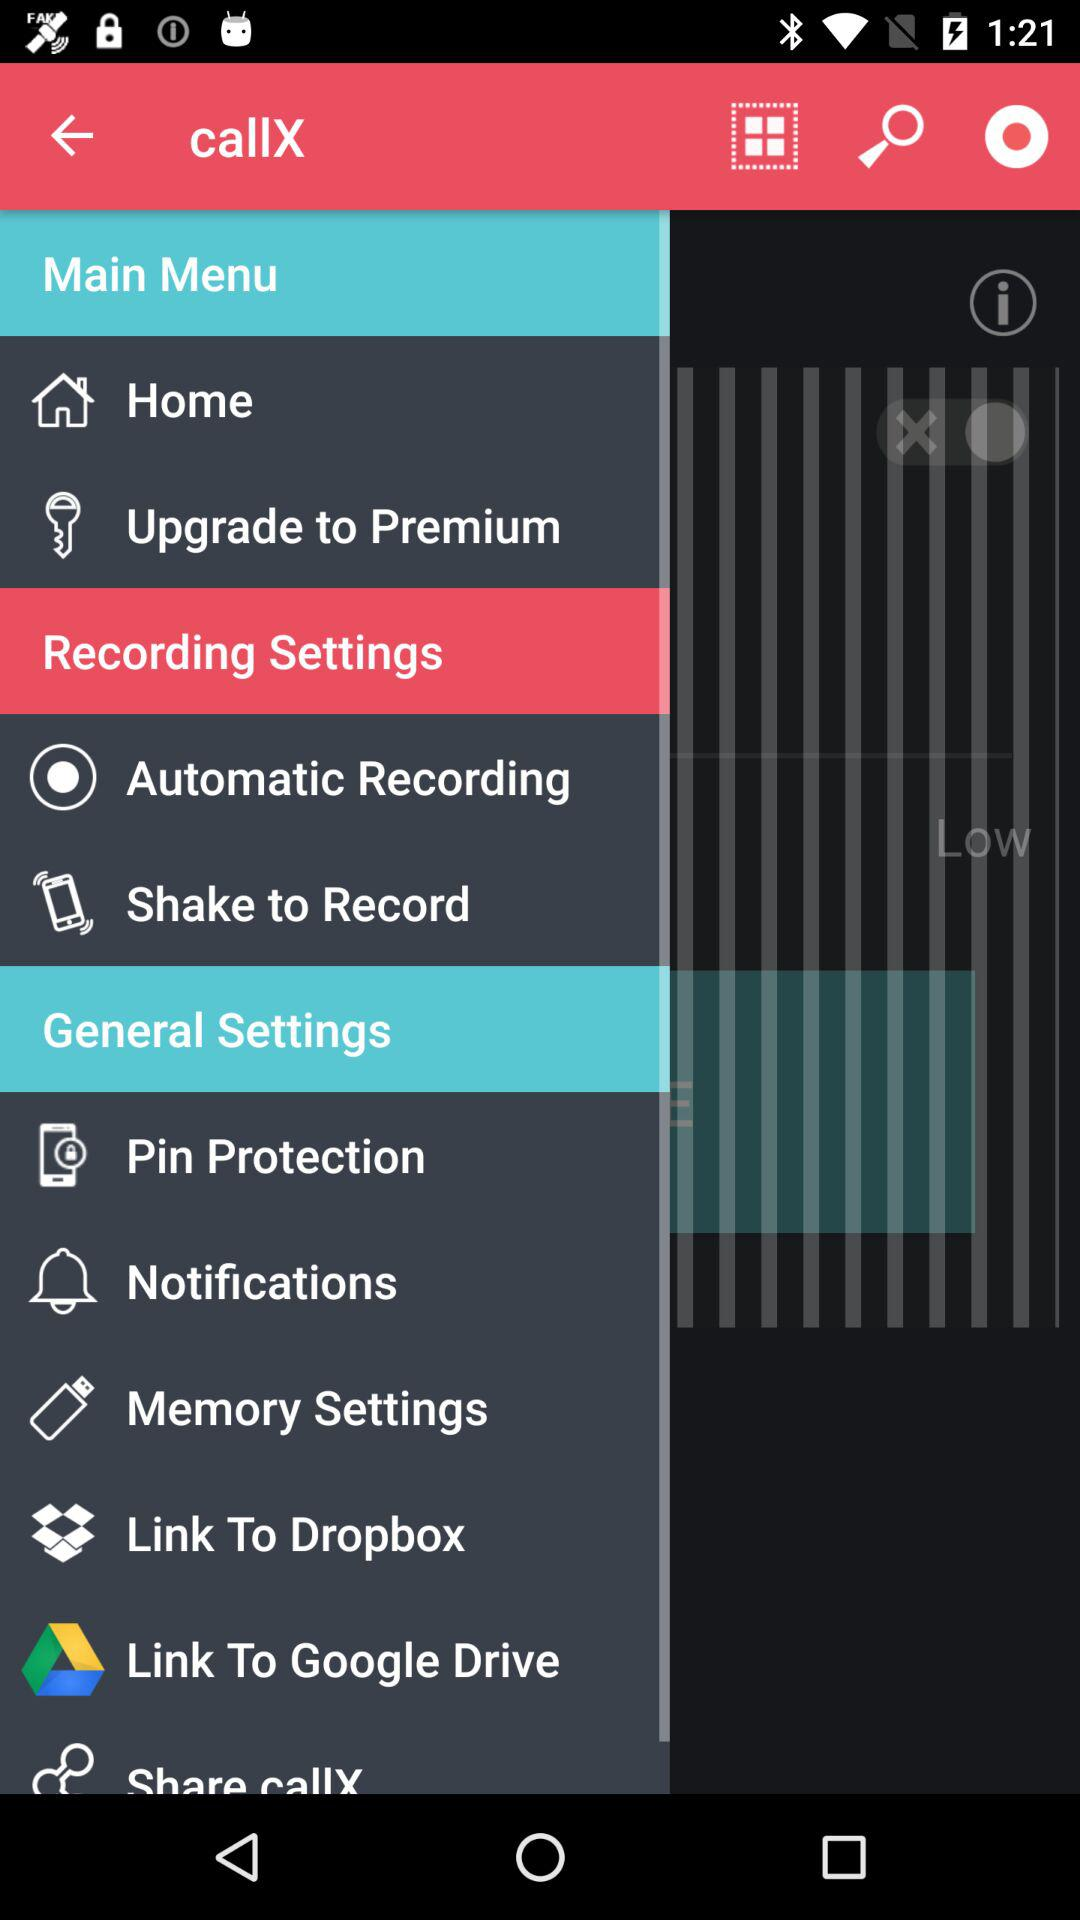What are the different types of "Recording Settings"? The different types of "Recording Settings" are "Automatic Recording" and "Shake to Record". 